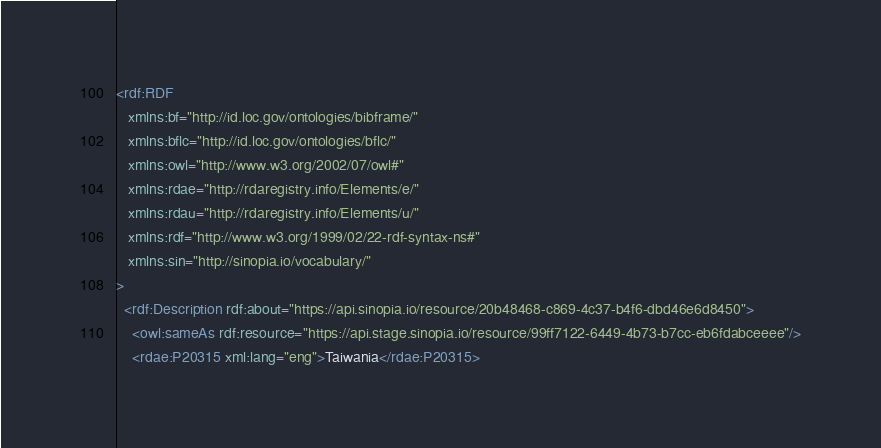<code> <loc_0><loc_0><loc_500><loc_500><_XML_><rdf:RDF
   xmlns:bf="http://id.loc.gov/ontologies/bibframe/"
   xmlns:bflc="http://id.loc.gov/ontologies/bflc/"
   xmlns:owl="http://www.w3.org/2002/07/owl#"
   xmlns:rdae="http://rdaregistry.info/Elements/e/"
   xmlns:rdau="http://rdaregistry.info/Elements/u/"
   xmlns:rdf="http://www.w3.org/1999/02/22-rdf-syntax-ns#"
   xmlns:sin="http://sinopia.io/vocabulary/"
>
  <rdf:Description rdf:about="https://api.sinopia.io/resource/20b48468-c869-4c37-b4f6-dbd46e6d8450">
    <owl:sameAs rdf:resource="https://api.stage.sinopia.io/resource/99ff7122-6449-4b73-b7cc-eb6fdabceeee"/>
    <rdae:P20315 xml:lang="eng">Taiwania</rdae:P20315></code> 